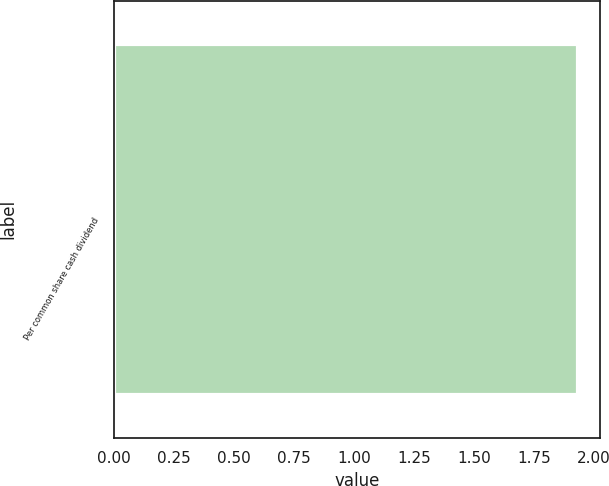<chart> <loc_0><loc_0><loc_500><loc_500><bar_chart><fcel>Per common share cash dividend<nl><fcel>1.93<nl></chart> 